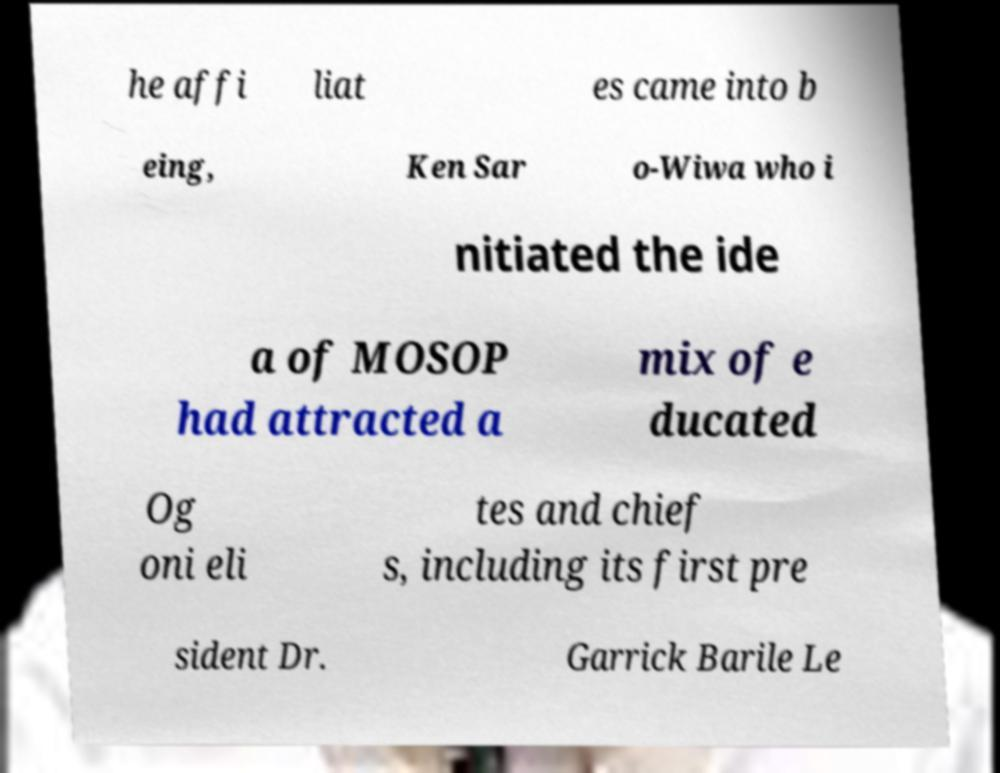There's text embedded in this image that I need extracted. Can you transcribe it verbatim? he affi liat es came into b eing, Ken Sar o-Wiwa who i nitiated the ide a of MOSOP had attracted a mix of e ducated Og oni eli tes and chief s, including its first pre sident Dr. Garrick Barile Le 